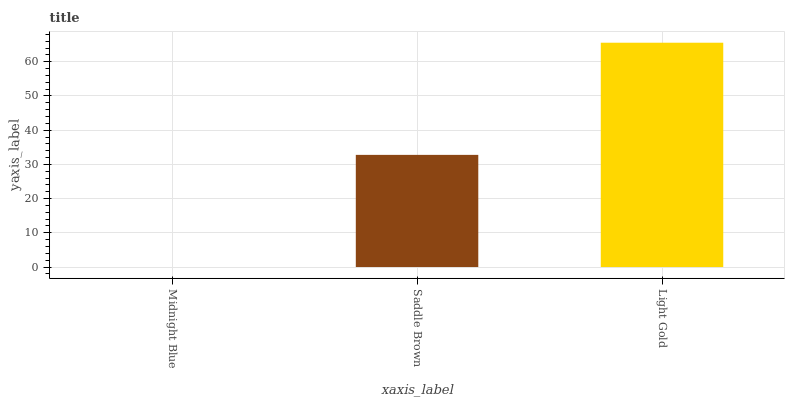Is Saddle Brown the minimum?
Answer yes or no. No. Is Saddle Brown the maximum?
Answer yes or no. No. Is Saddle Brown greater than Midnight Blue?
Answer yes or no. Yes. Is Midnight Blue less than Saddle Brown?
Answer yes or no. Yes. Is Midnight Blue greater than Saddle Brown?
Answer yes or no. No. Is Saddle Brown less than Midnight Blue?
Answer yes or no. No. Is Saddle Brown the high median?
Answer yes or no. Yes. Is Saddle Brown the low median?
Answer yes or no. Yes. Is Midnight Blue the high median?
Answer yes or no. No. Is Midnight Blue the low median?
Answer yes or no. No. 